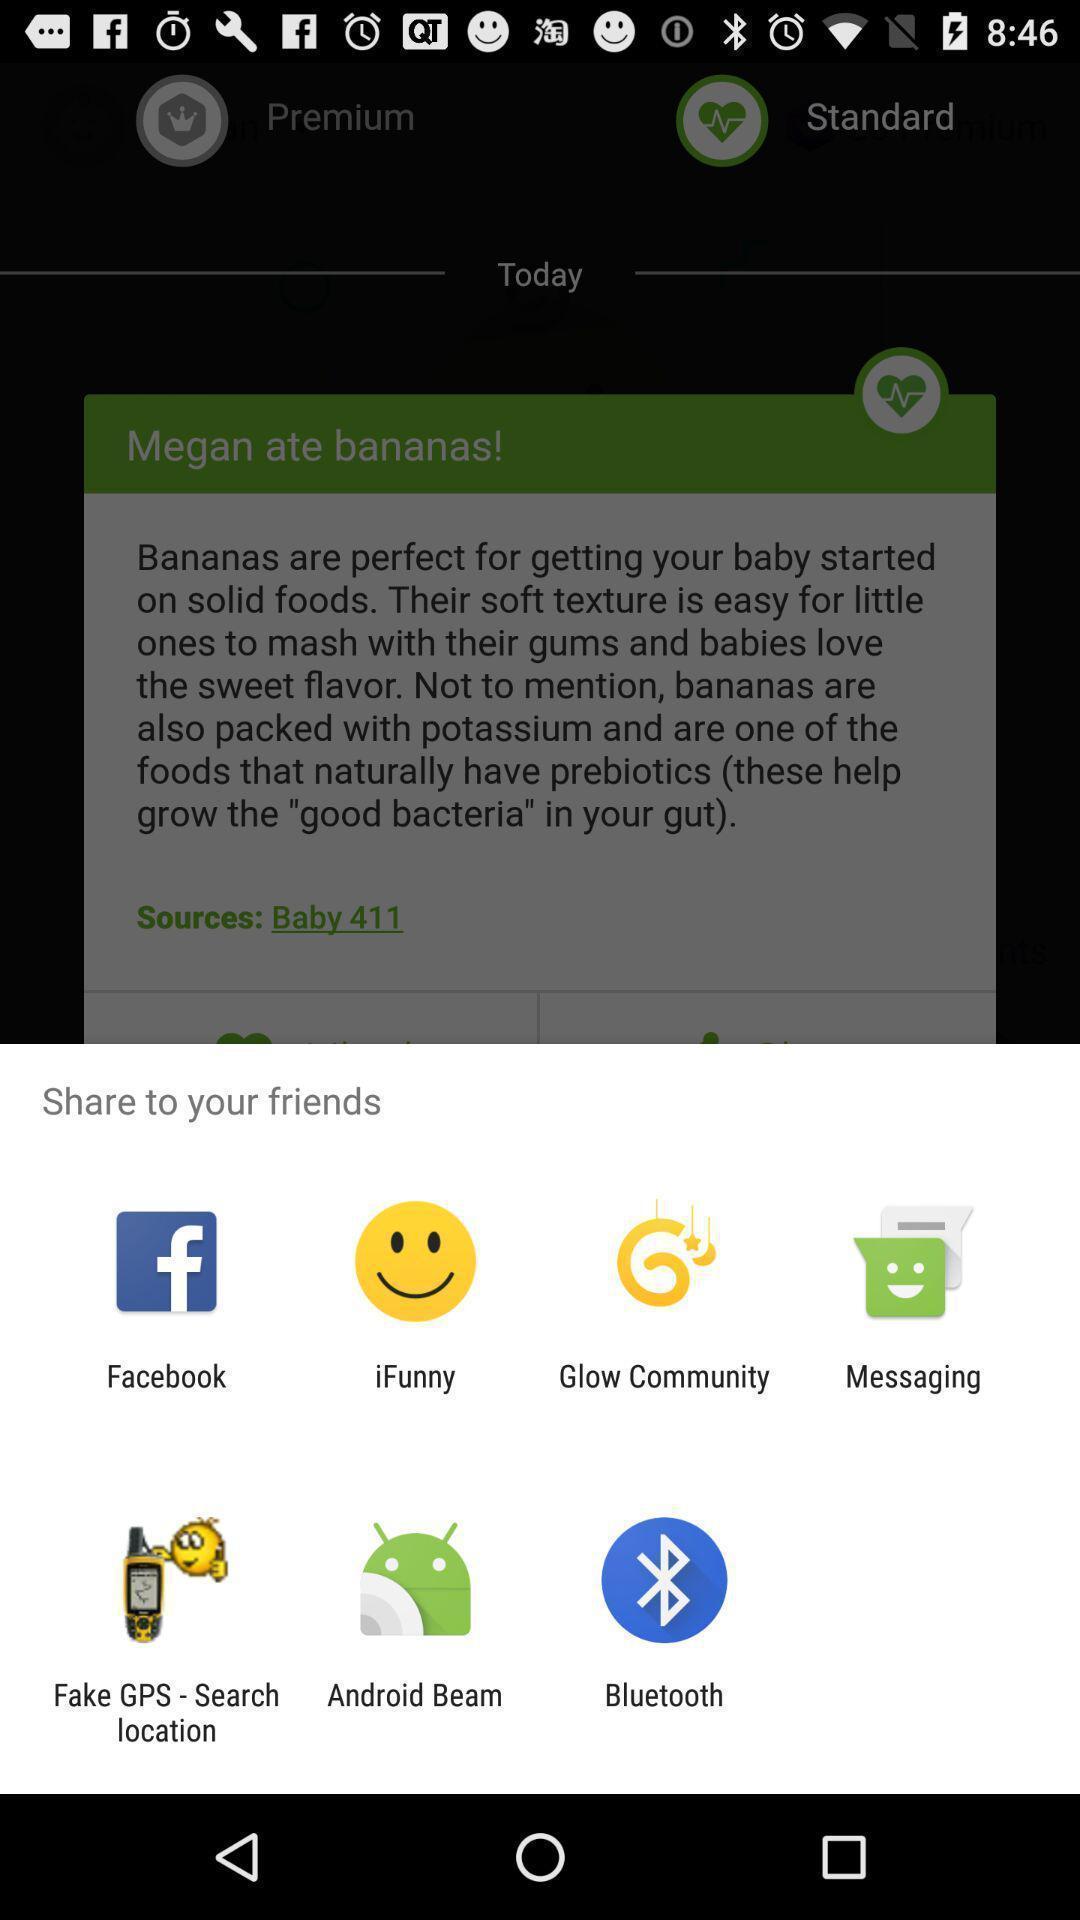Provide a detailed account of this screenshot. Popup showing few sharing options with icons in health app. 